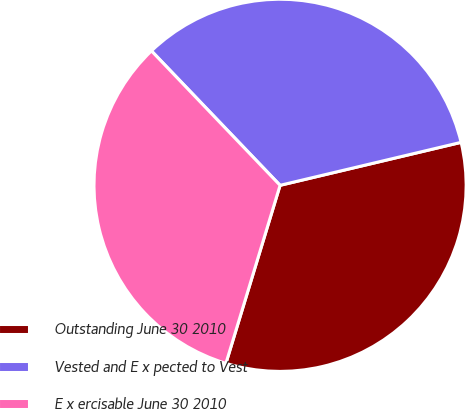Convert chart to OTSL. <chart><loc_0><loc_0><loc_500><loc_500><pie_chart><fcel>Outstanding June 30 2010<fcel>Vested and E x pected to Vest<fcel>E x ercisable June 30 2010<nl><fcel>33.41%<fcel>33.44%<fcel>33.15%<nl></chart> 